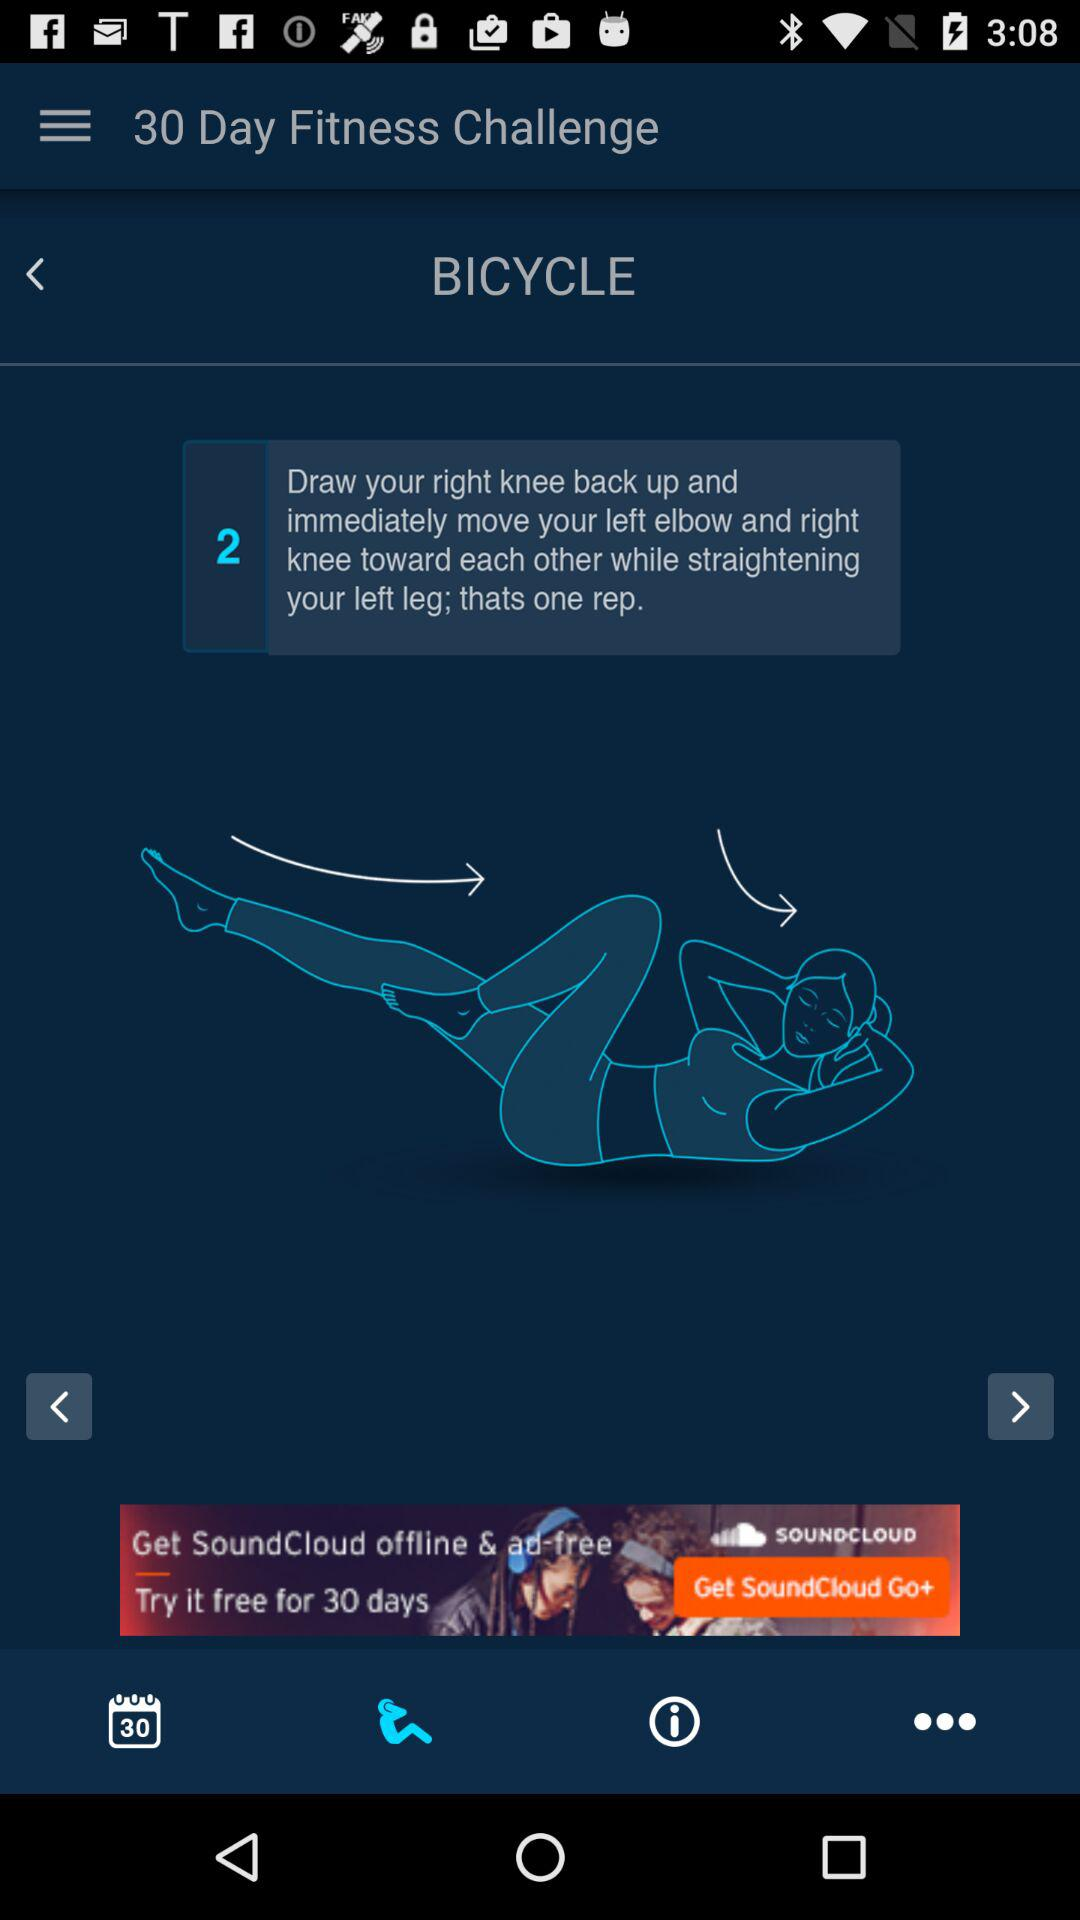How many reps of the bicycle exercise are there?
Answer the question using a single word or phrase. 2 